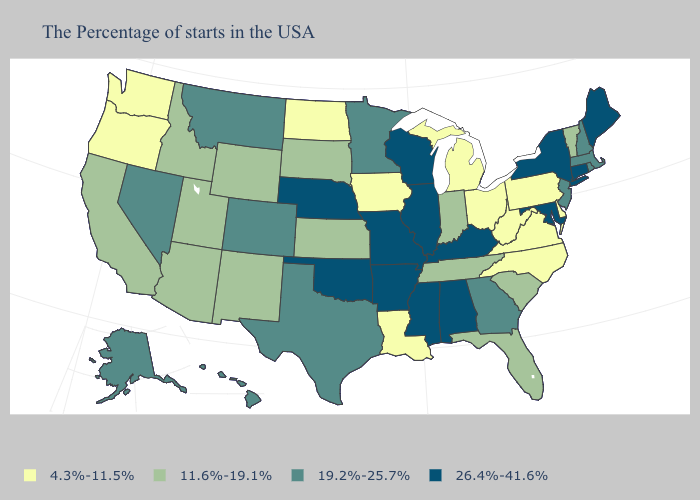Does Missouri have the same value as New York?
Give a very brief answer. Yes. Among the states that border New Mexico , does Oklahoma have the lowest value?
Be succinct. No. Among the states that border Vermont , which have the lowest value?
Answer briefly. Massachusetts, New Hampshire. Which states have the lowest value in the MidWest?
Quick response, please. Ohio, Michigan, Iowa, North Dakota. What is the value of Rhode Island?
Quick response, please. 19.2%-25.7%. Name the states that have a value in the range 11.6%-19.1%?
Concise answer only. Vermont, South Carolina, Florida, Indiana, Tennessee, Kansas, South Dakota, Wyoming, New Mexico, Utah, Arizona, Idaho, California. Does Pennsylvania have the highest value in the Northeast?
Concise answer only. No. What is the value of Mississippi?
Be succinct. 26.4%-41.6%. What is the value of Delaware?
Quick response, please. 4.3%-11.5%. Does the first symbol in the legend represent the smallest category?
Answer briefly. Yes. Name the states that have a value in the range 26.4%-41.6%?
Give a very brief answer. Maine, Connecticut, New York, Maryland, Kentucky, Alabama, Wisconsin, Illinois, Mississippi, Missouri, Arkansas, Nebraska, Oklahoma. Among the states that border Utah , which have the lowest value?
Short answer required. Wyoming, New Mexico, Arizona, Idaho. Does Kentucky have a lower value than New Hampshire?
Quick response, please. No. Does Kansas have a higher value than North Carolina?
Concise answer only. Yes. What is the value of Massachusetts?
Be succinct. 19.2%-25.7%. 